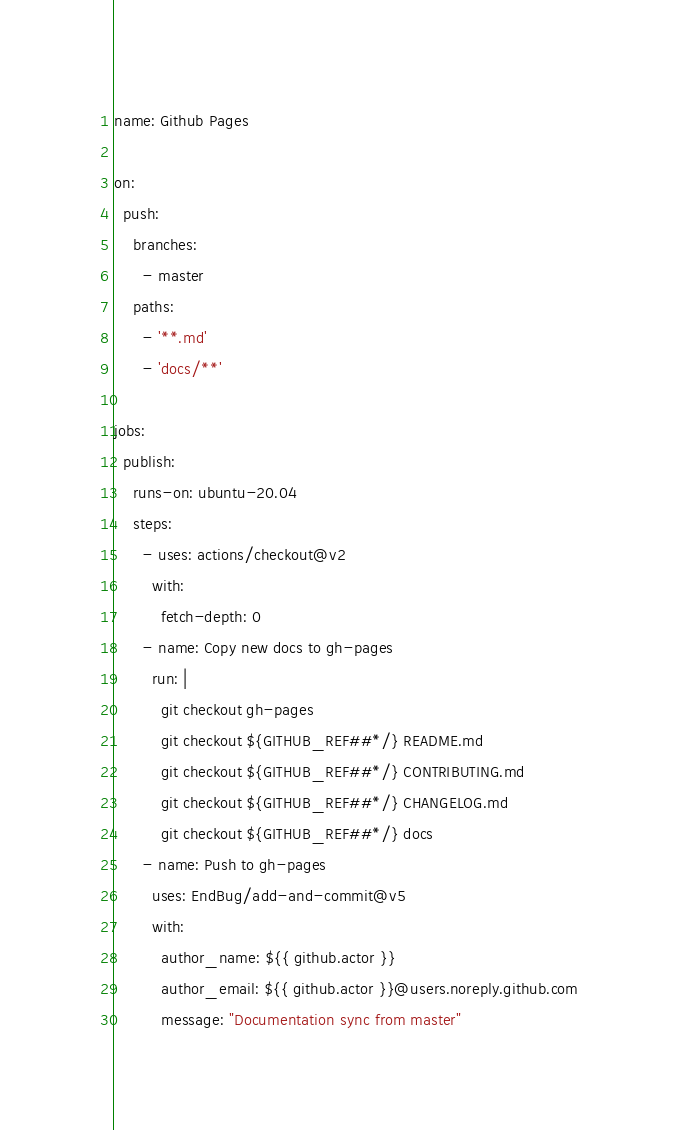<code> <loc_0><loc_0><loc_500><loc_500><_YAML_>name: Github Pages

on:
  push:
    branches:
      - master
    paths:
      - '**.md'
      - 'docs/**'

jobs:
  publish:
    runs-on: ubuntu-20.04
    steps:
      - uses: actions/checkout@v2
        with:
          fetch-depth: 0
      - name: Copy new docs to gh-pages
        run: |
          git checkout gh-pages
          git checkout ${GITHUB_REF##*/} README.md
          git checkout ${GITHUB_REF##*/} CONTRIBUTING.md
          git checkout ${GITHUB_REF##*/} CHANGELOG.md
          git checkout ${GITHUB_REF##*/} docs
      - name: Push to gh-pages
        uses: EndBug/add-and-commit@v5
        with:
          author_name: ${{ github.actor }}
          author_email: ${{ github.actor }}@users.noreply.github.com
          message: "Documentation sync from master"</code> 